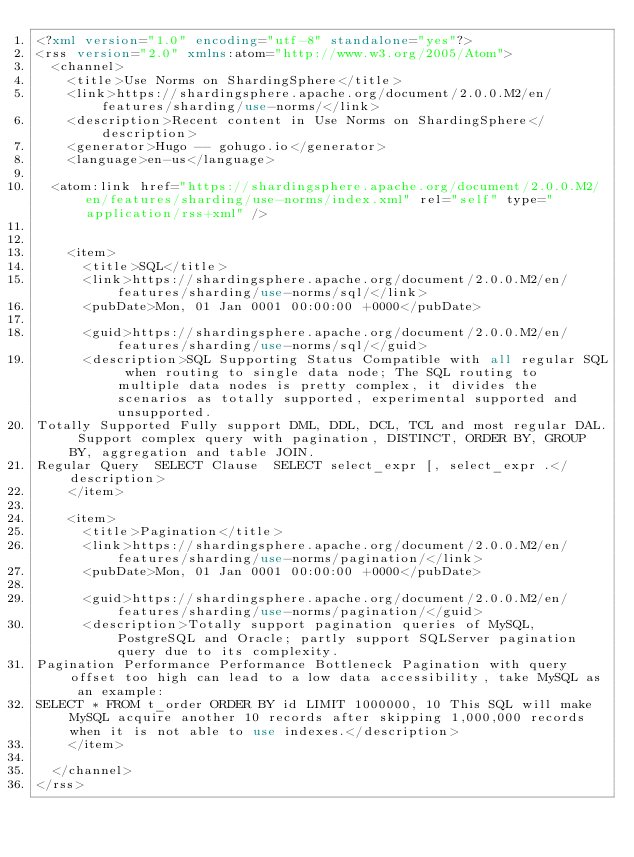Convert code to text. <code><loc_0><loc_0><loc_500><loc_500><_XML_><?xml version="1.0" encoding="utf-8" standalone="yes"?>
<rss version="2.0" xmlns:atom="http://www.w3.org/2005/Atom">
  <channel>
    <title>Use Norms on ShardingSphere</title>
    <link>https://shardingsphere.apache.org/document/2.0.0.M2/en/features/sharding/use-norms/</link>
    <description>Recent content in Use Norms on ShardingSphere</description>
    <generator>Hugo -- gohugo.io</generator>
    <language>en-us</language>
    
	<atom:link href="https://shardingsphere.apache.org/document/2.0.0.M2/en/features/sharding/use-norms/index.xml" rel="self" type="application/rss+xml" />
    
    
    <item>
      <title>SQL</title>
      <link>https://shardingsphere.apache.org/document/2.0.0.M2/en/features/sharding/use-norms/sql/</link>
      <pubDate>Mon, 01 Jan 0001 00:00:00 +0000</pubDate>
      
      <guid>https://shardingsphere.apache.org/document/2.0.0.M2/en/features/sharding/use-norms/sql/</guid>
      <description>SQL Supporting Status Compatible with all regular SQL when routing to single data node; The SQL routing to multiple data nodes is pretty complex, it divides the scenarios as totally supported, experimental supported and unsupported.
Totally Supported Fully support DML, DDL, DCL, TCL and most regular DAL. Support complex query with pagination, DISTINCT, ORDER BY, GROUP BY, aggregation and table JOIN.
Regular Query  SELECT Clause  SELECT select_expr [, select_expr .</description>
    </item>
    
    <item>
      <title>Pagination</title>
      <link>https://shardingsphere.apache.org/document/2.0.0.M2/en/features/sharding/use-norms/pagination/</link>
      <pubDate>Mon, 01 Jan 0001 00:00:00 +0000</pubDate>
      
      <guid>https://shardingsphere.apache.org/document/2.0.0.M2/en/features/sharding/use-norms/pagination/</guid>
      <description>Totally support pagination queries of MySQL, PostgreSQL and Oracle; partly support SQLServer pagination query due to its complexity.
Pagination Performance Performance Bottleneck Pagination with query offset too high can lead to a low data accessibility, take MySQL as an example:
SELECT * FROM t_order ORDER BY id LIMIT 1000000, 10 This SQL will make MySQL acquire another 10 records after skipping 1,000,000 records when it is not able to use indexes.</description>
    </item>
    
  </channel>
</rss></code> 